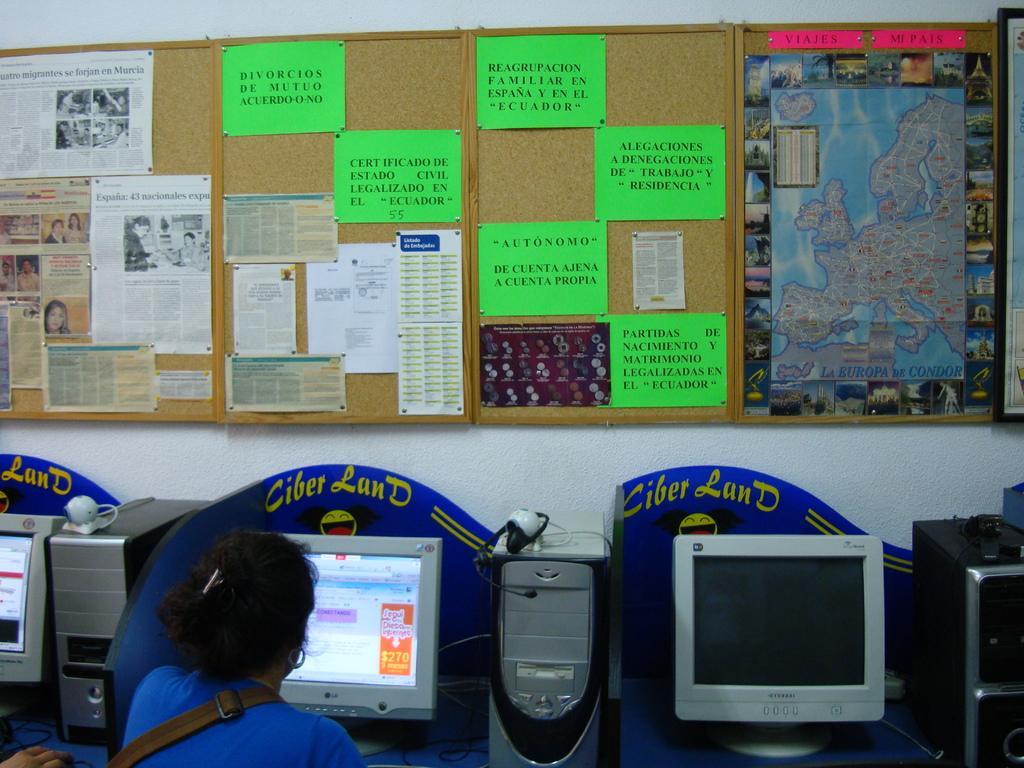How would you summarize this image in a sentence or two? In this picture there is a woman who is sitting near to the table. On the table I can see the computer screens, CPU, mouse and camera. In the center I can see many posters and papers were attached on the boards. This board is placed on the wall. 